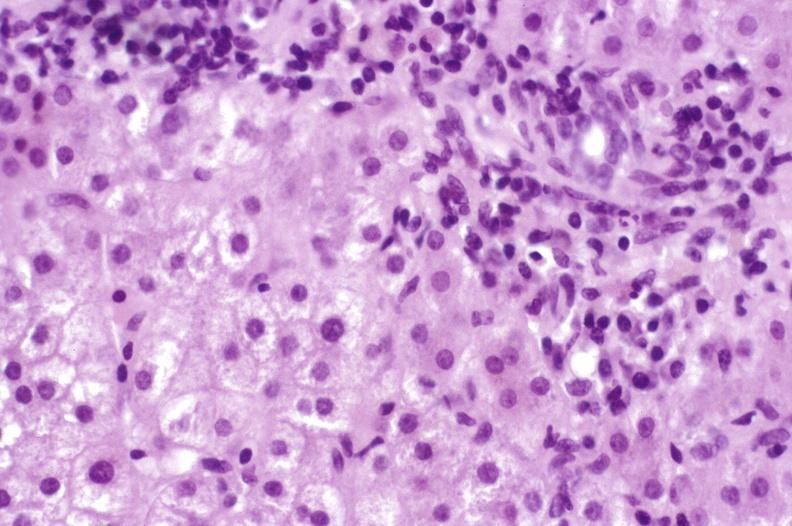s chronic ischemia present?
Answer the question using a single word or phrase. No 